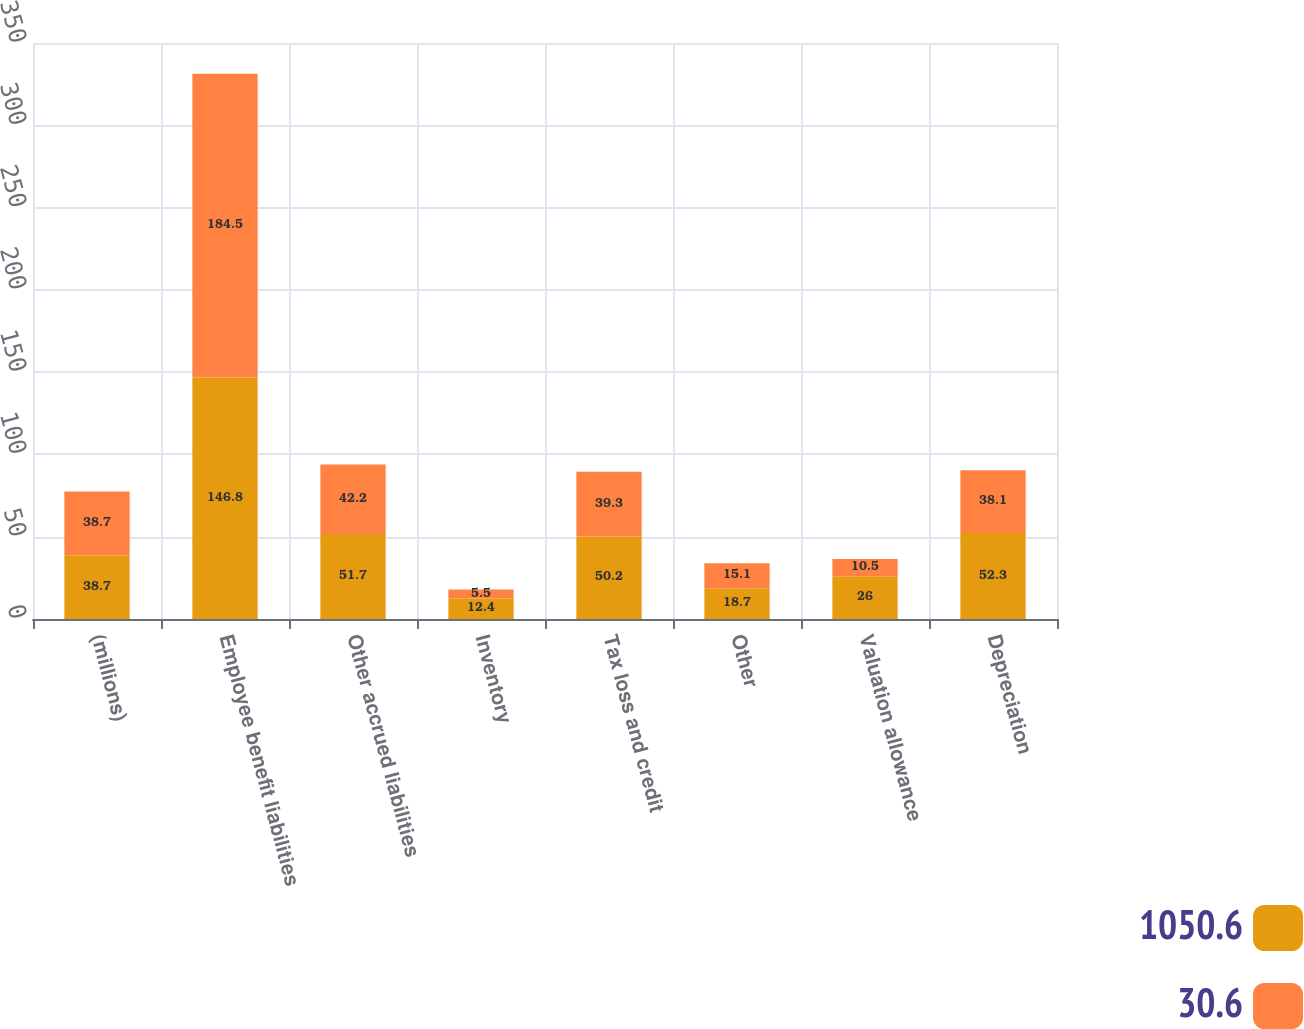<chart> <loc_0><loc_0><loc_500><loc_500><stacked_bar_chart><ecel><fcel>(millions)<fcel>Employee benefit liabilities<fcel>Other accrued liabilities<fcel>Inventory<fcel>Tax loss and credit<fcel>Other<fcel>Valuation allowance<fcel>Depreciation<nl><fcel>1050.6<fcel>38.7<fcel>146.8<fcel>51.7<fcel>12.4<fcel>50.2<fcel>18.7<fcel>26<fcel>52.3<nl><fcel>30.6<fcel>38.7<fcel>184.5<fcel>42.2<fcel>5.5<fcel>39.3<fcel>15.1<fcel>10.5<fcel>38.1<nl></chart> 